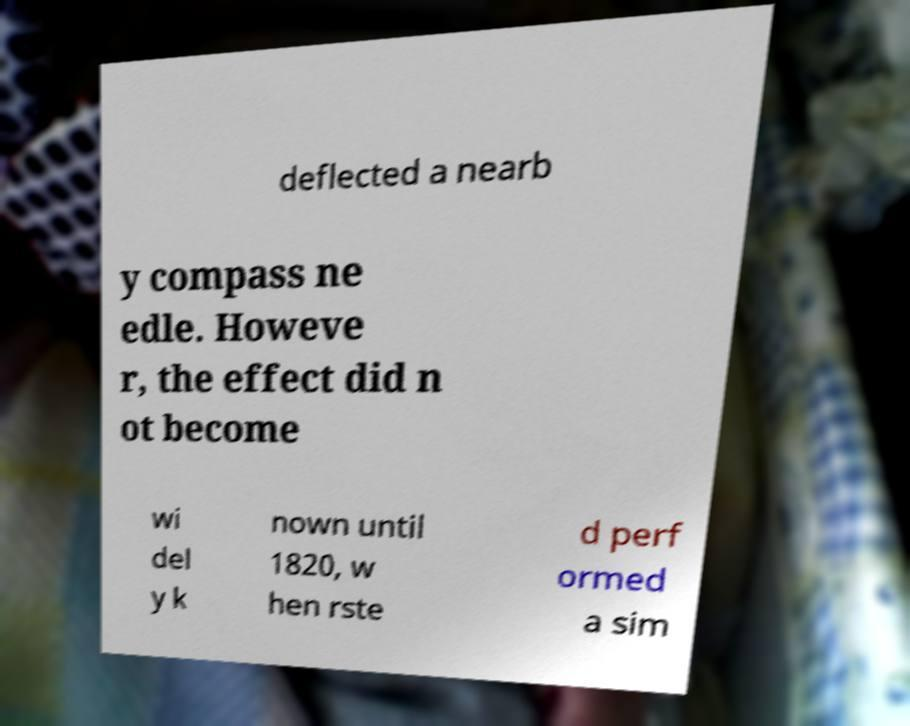For documentation purposes, I need the text within this image transcribed. Could you provide that? deflected a nearb y compass ne edle. Howeve r, the effect did n ot become wi del y k nown until 1820, w hen rste d perf ormed a sim 